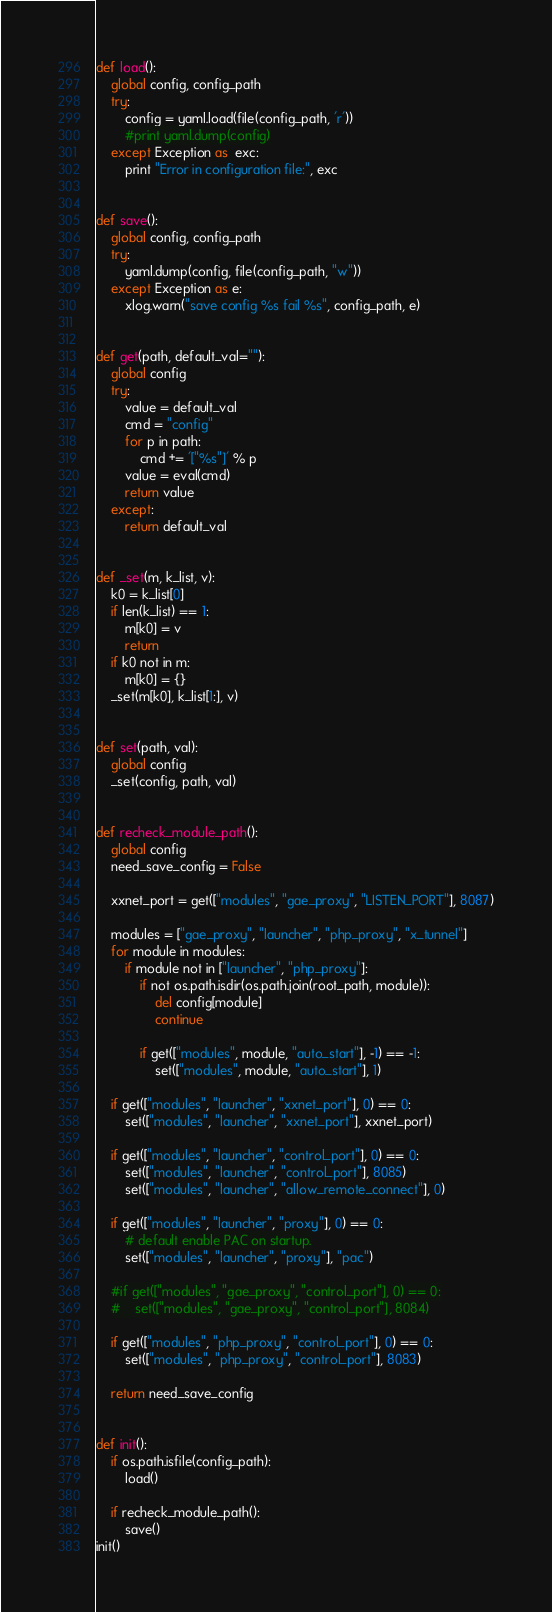<code> <loc_0><loc_0><loc_500><loc_500><_Python_>def load():
    global config, config_path
    try:
        config = yaml.load(file(config_path, 'r'))
        #print yaml.dump(config)
    except Exception as  exc:
        print "Error in configuration file:", exc


def save():
    global config, config_path
    try:
        yaml.dump(config, file(config_path, "w"))
    except Exception as e:
        xlog.warn("save config %s fail %s", config_path, e)


def get(path, default_val=""):
    global config
    try:
        value = default_val
        cmd = "config"
        for p in path:
            cmd += '["%s"]' % p
        value = eval(cmd)
        return value
    except:
        return default_val


def _set(m, k_list, v):
    k0 = k_list[0]
    if len(k_list) == 1:
        m[k0] = v
        return
    if k0 not in m:
        m[k0] = {}
    _set(m[k0], k_list[1:], v)


def set(path, val):
    global config
    _set(config, path, val)


def recheck_module_path():
    global config
    need_save_config = False

    xxnet_port = get(["modules", "gae_proxy", "LISTEN_PORT"], 8087)

    modules = ["gae_proxy", "launcher", "php_proxy", "x_tunnel"]
    for module in modules:
        if module not in ["launcher", "php_proxy"]:
            if not os.path.isdir(os.path.join(root_path, module)):
                del config[module]
                continue

            if get(["modules", module, "auto_start"], -1) == -1:
                set(["modules", module, "auto_start"], 1)

    if get(["modules", "launcher", "xxnet_port"], 0) == 0:
        set(["modules", "launcher", "xxnet_port"], xxnet_port)

    if get(["modules", "launcher", "control_port"], 0) == 0:
        set(["modules", "launcher", "control_port"], 8085)
        set(["modules", "launcher", "allow_remote_connect"], 0)

    if get(["modules", "launcher", "proxy"], 0) == 0:
        # default enable PAC on startup.
        set(["modules", "launcher", "proxy"], "pac")

    #if get(["modules", "gae_proxy", "control_port"], 0) == 0:
    #    set(["modules", "gae_proxy", "control_port"], 8084)

    if get(["modules", "php_proxy", "control_port"], 0) == 0:
        set(["modules", "php_proxy", "control_port"], 8083)

    return need_save_config


def init():
    if os.path.isfile(config_path):
        load()

    if recheck_module_path():
        save()
init()
</code> 